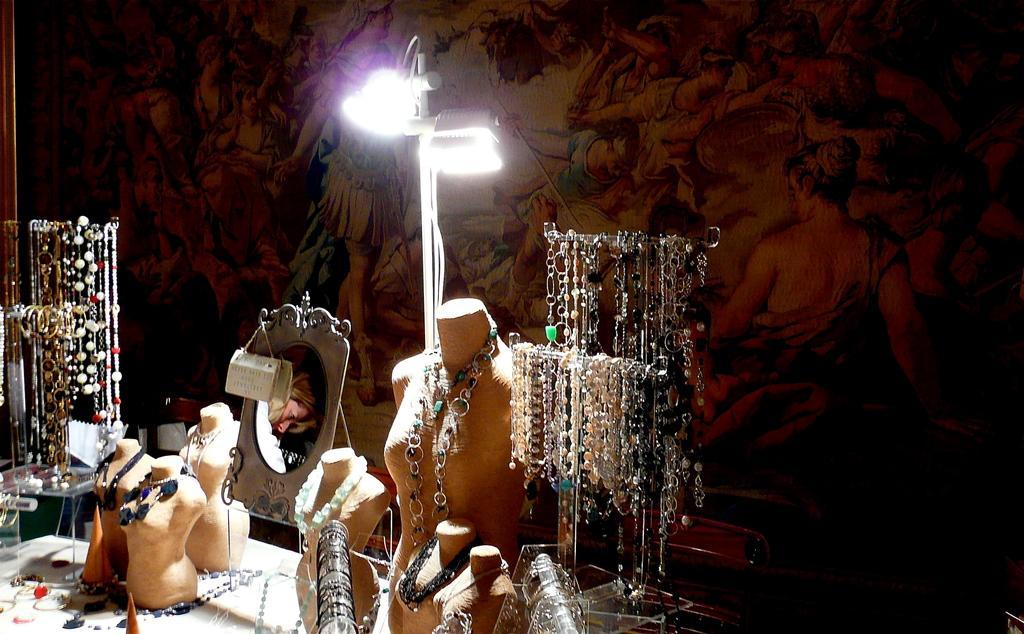Please provide a concise description of this image. In this image I can see the many mannequins with chains, mirror and these are on the white color surface. To the side I can see few more chains hanged to the metal rod. In the background I can see the lights and the wall painting. 